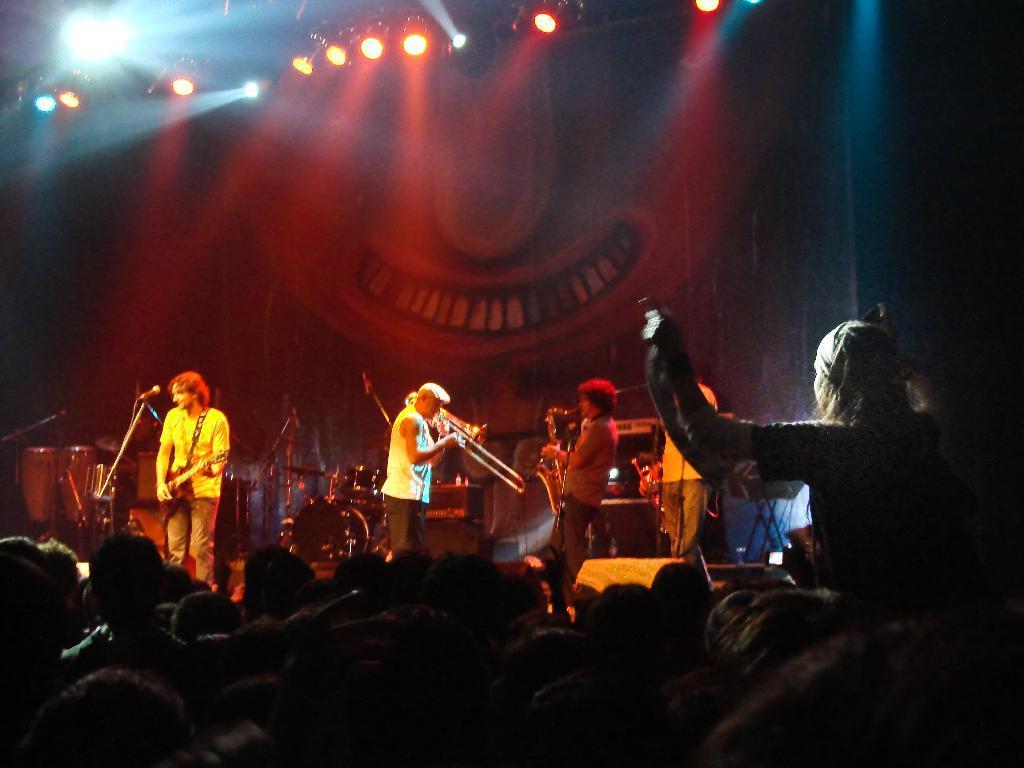In one or two sentences, can you explain what this image depicts? In this picture we can see three people standing here, a man on the left side is playing a guitar, we can see a microphone here, in the front there are some people here, we can see some lights here. 